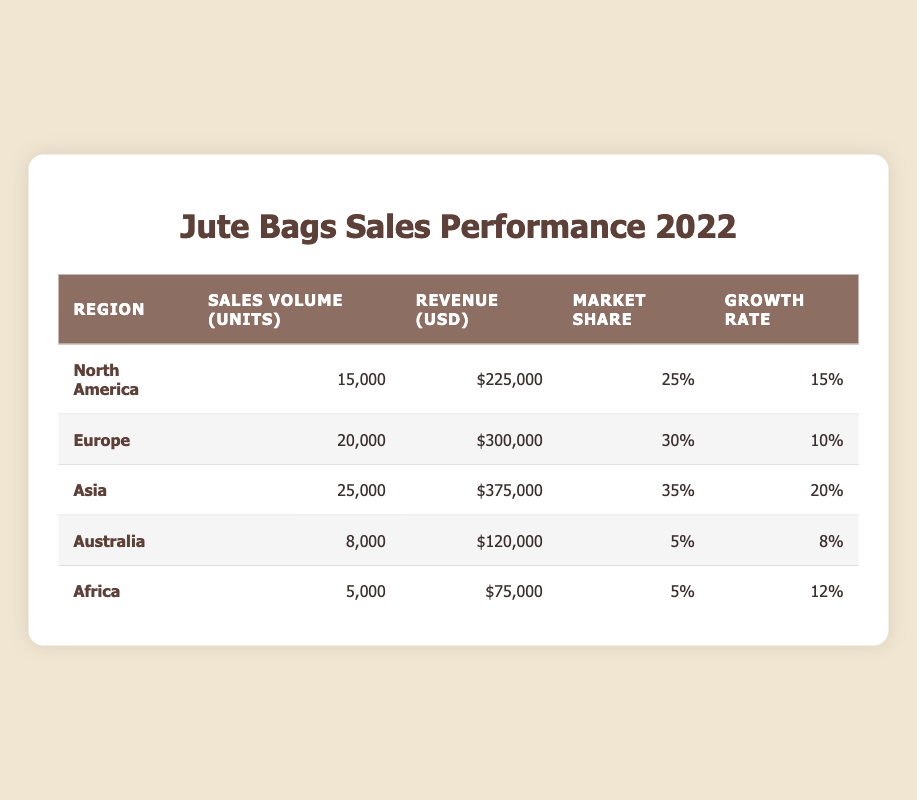What is the sales volume of jute bags in Asia? The table lists the sales volume for Asia as 25,000 units.
Answer: 25,000 Which region has the highest revenue from jute bags? By comparing the revenue figures, Asia has the highest revenue at $375,000.
Answer: Asia What is the combined sales volume of jute bags in North America and Australia? The sales volumes for North America and Australia are 15,000 and 8,000 respectively. Their combined sales volume is 15,000 + 8,000 = 23,000 units.
Answer: 23,000 Is the market share percentage for Europe greater than that for Africa? Europe has a market share of 30%, while Africa has 5%. Since 30% is greater than 5%, the statement is true.
Answer: Yes What is the average growth rate for jute bag sales across all regions? To find the average growth rate, add all growth rates: (15 + 10 + 20 + 8 + 12) = 65, then divide by the number of regions (5): 65 / 5 = 13.
Answer: 13 Which region experienced the lowest market share percentage and what is that percentage? The lowest market share percentage is 5%, recorded in both Australia and Africa.
Answer: 5 How much did the growth rate for jute bag sales in Asia exceed that of Australia? Asia's growth rate is 20%, while Australia's is 8%. The difference is 20 - 8 = 12%.
Answer: 12% Which region's sales volume is the closest to 10,000 units? Australia has a sales volume of 8,000 units, which is the closest to 10,000 in the table.
Answer: Australia What is the total revenue earned from jute bag sales across all regions? The total revenue is calculated by summing all regions' revenue: 225,000 + 300,000 + 375,000 + 120,000 + 75,000 = 1,095,000.
Answer: 1,095,000 